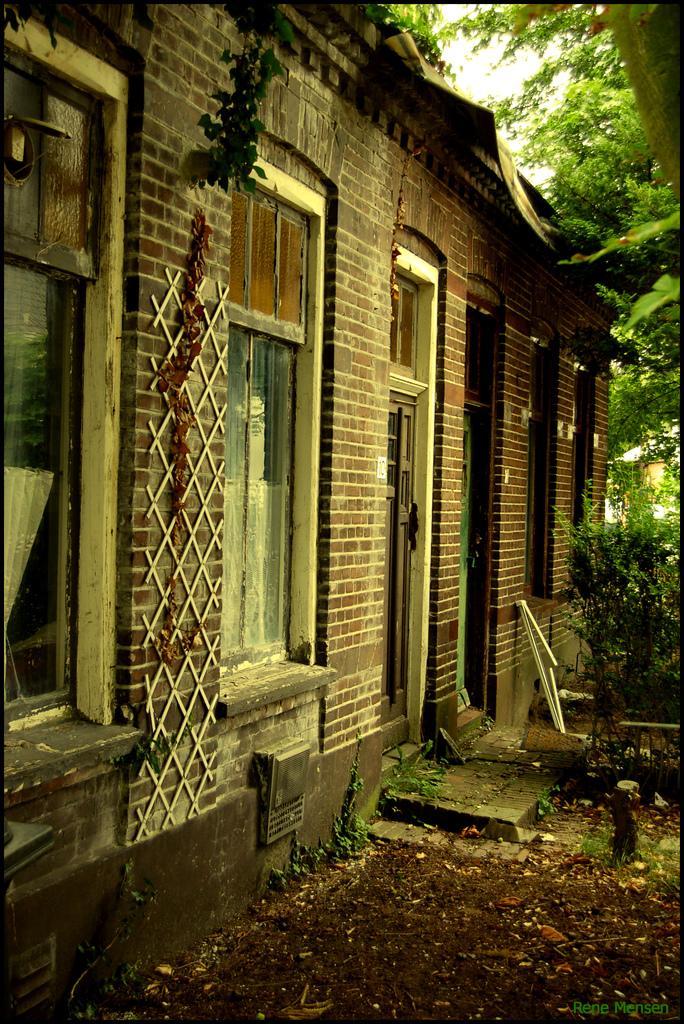Please provide a concise description of this image. In this image in the front there is a building and there are windows and there are trees on the right side, there are dry leaves on the ground and the sky is cloudy. 